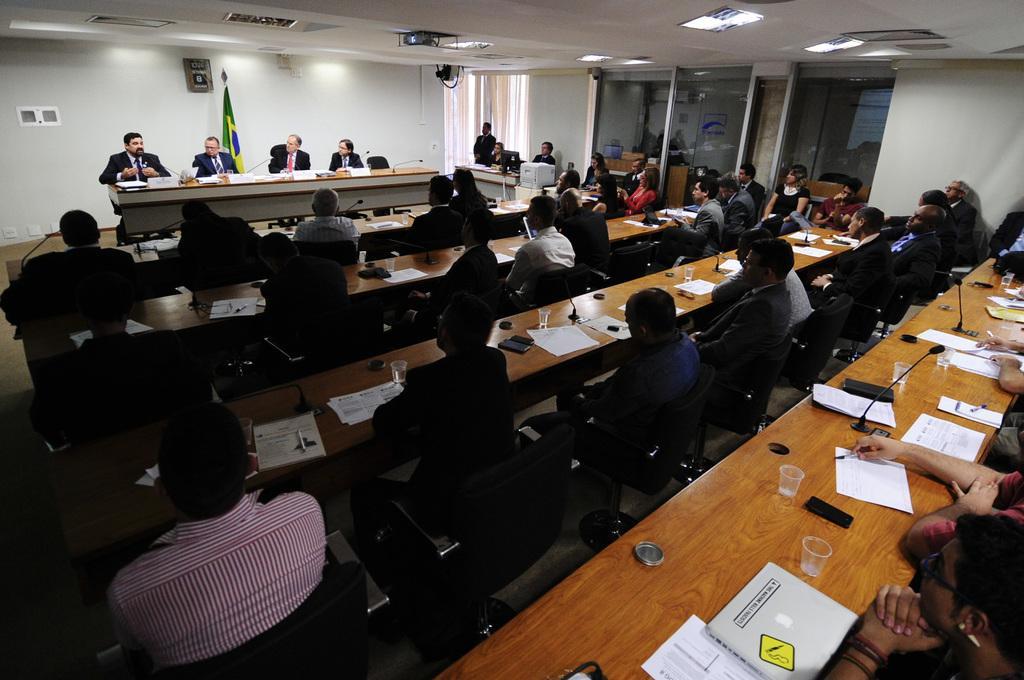How would you summarize this image in a sentence or two? In this image we can see few persons are sitting on the chairs at the tables. On the tables we can see papers, glasses and objects. In the background we can see objects on the wall, flag pole, glasses, lights and projector on the ceiling. 